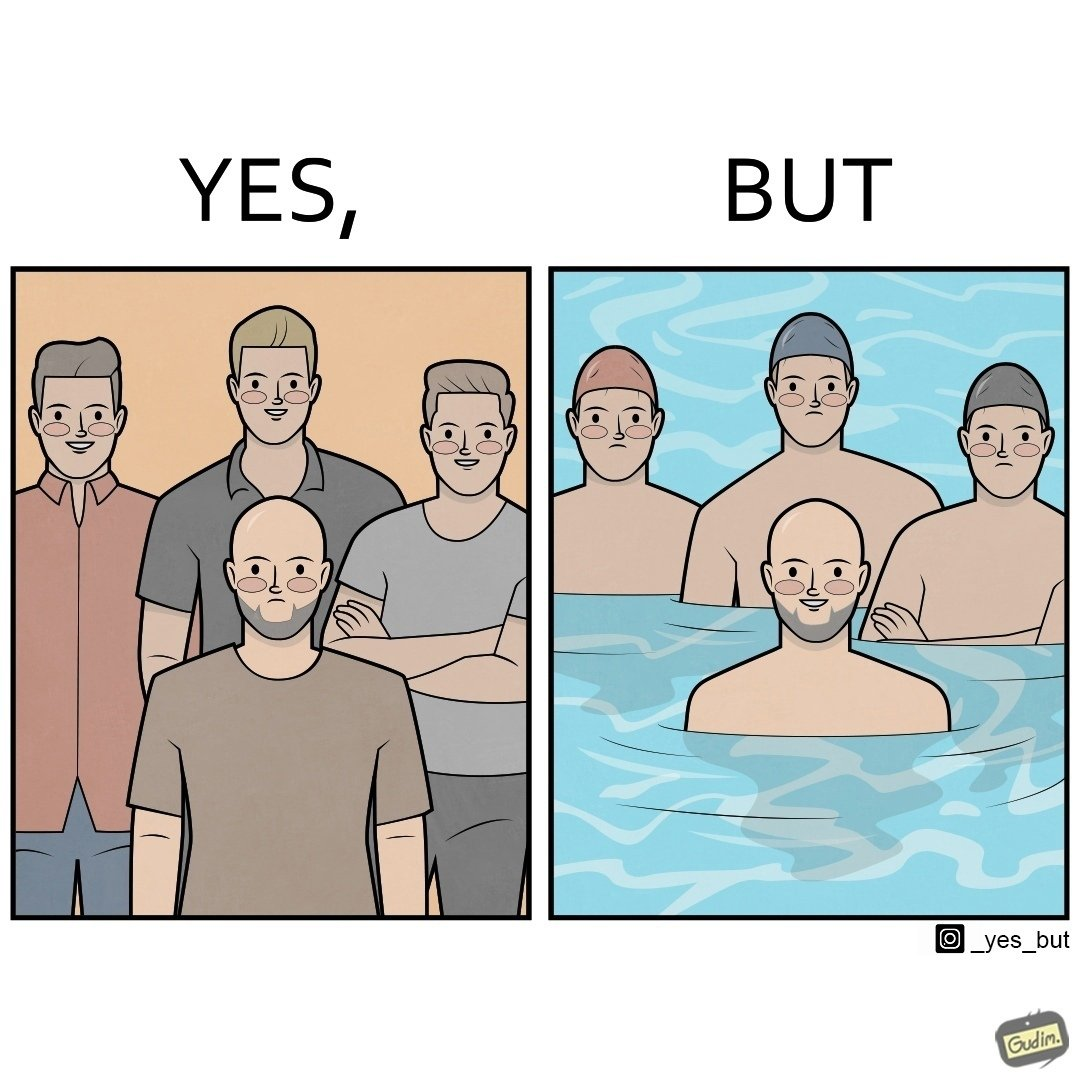Describe what you see in the left and right parts of this image. In the left part of the image: Three happy people with heads full of hair standing behind a sad person with no hair. In the right part of the image: Three sad people wearing swimming caps standing behind a happy person with no hair in a swimming pool. 